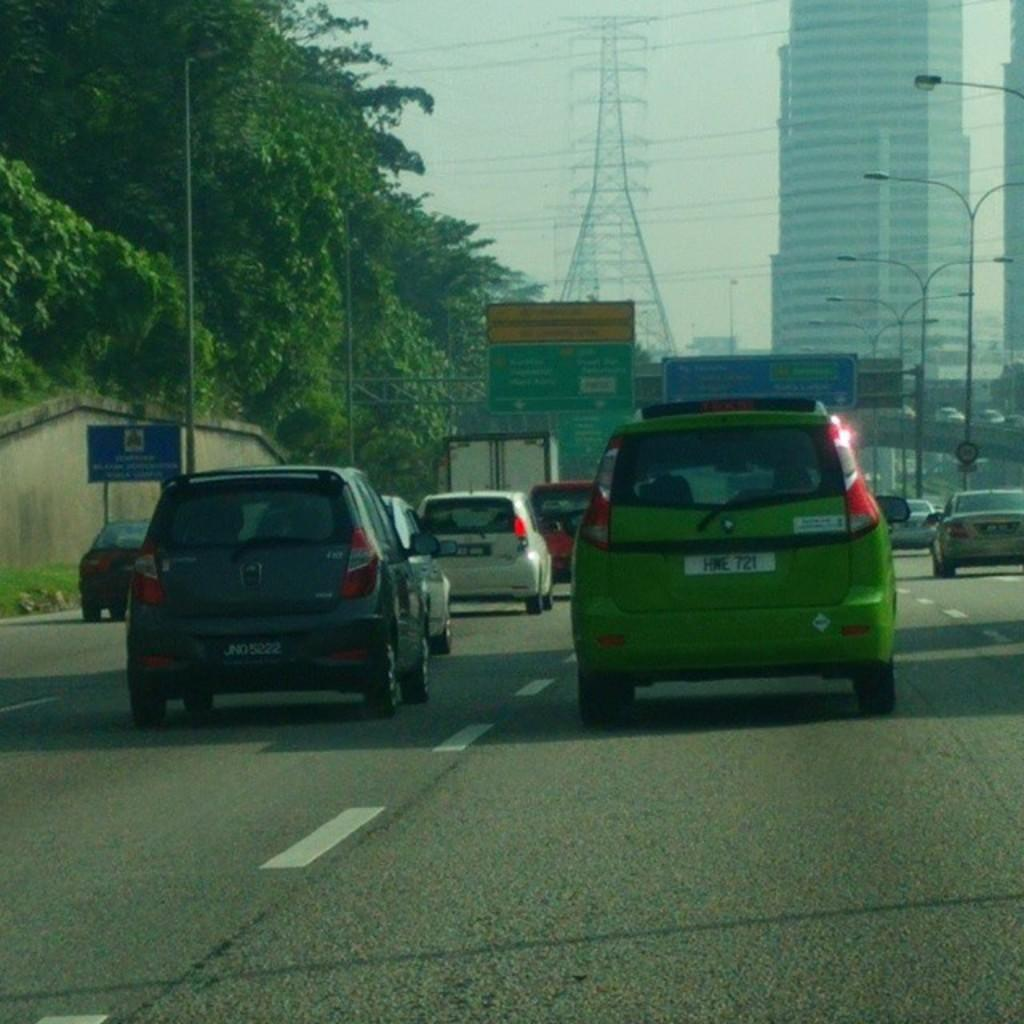What is located at the bottom of the image? There are cars, a road, a board, and grass at the bottom of the image. What can be seen in the middle of the image? There are trees, poles, street lights, sign boards, a tower, and buildings in the middle of the image. What is visible in the sky in the middle of the image? The sky is visible in the middle of the image. How many chickens are crossing the road in the image? There are no chickens present in the image. What type of slope can be seen in the image? There is no slope visible in the image. 